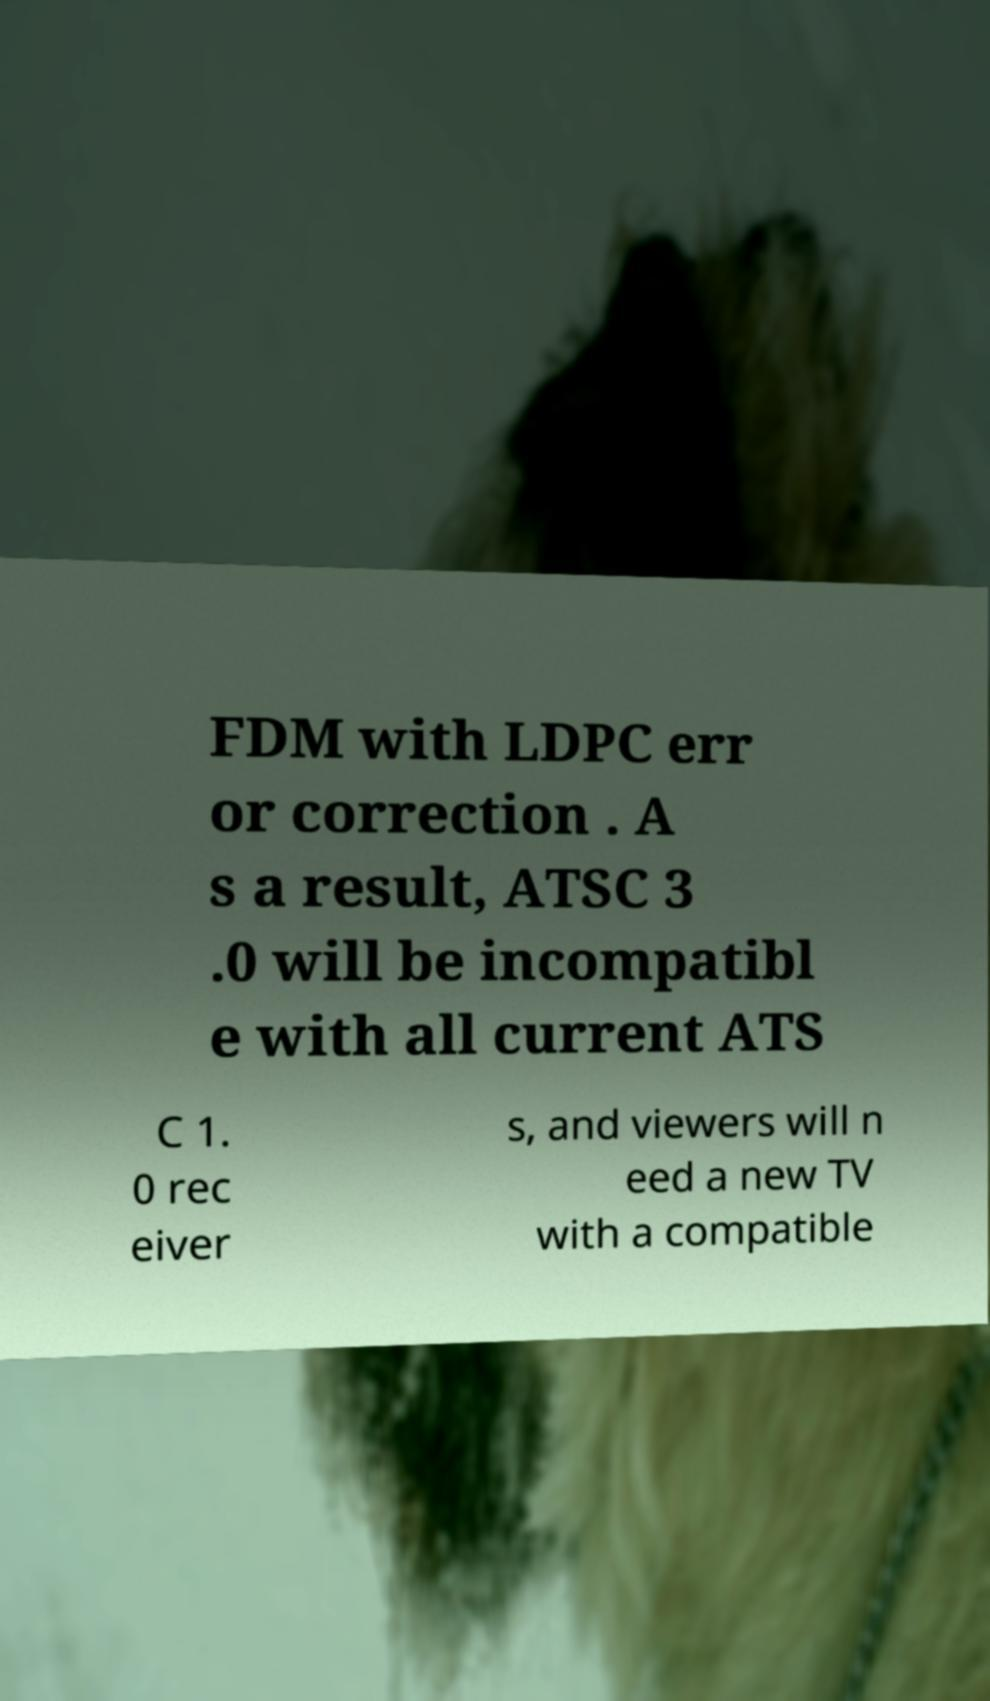I need the written content from this picture converted into text. Can you do that? FDM with LDPC err or correction . A s a result, ATSC 3 .0 will be incompatibl e with all current ATS C 1. 0 rec eiver s, and viewers will n eed a new TV with a compatible 